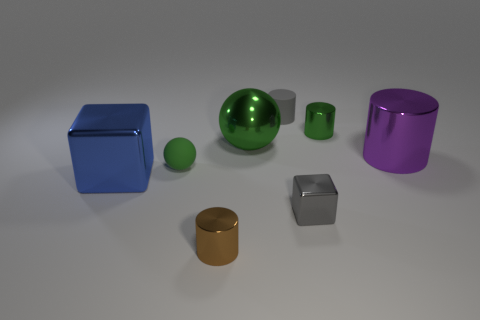Subtract all tiny gray rubber cylinders. How many cylinders are left? 3 Subtract all purple cylinders. How many cylinders are left? 3 Add 2 blue things. How many objects exist? 10 Subtract all balls. How many objects are left? 6 Subtract all yellow cylinders. How many blue blocks are left? 1 Subtract all red blocks. Subtract all red balls. How many blocks are left? 2 Subtract all rubber cylinders. Subtract all small brown cylinders. How many objects are left? 6 Add 6 big metallic cylinders. How many big metallic cylinders are left? 7 Add 7 gray matte cubes. How many gray matte cubes exist? 7 Subtract 1 brown cylinders. How many objects are left? 7 